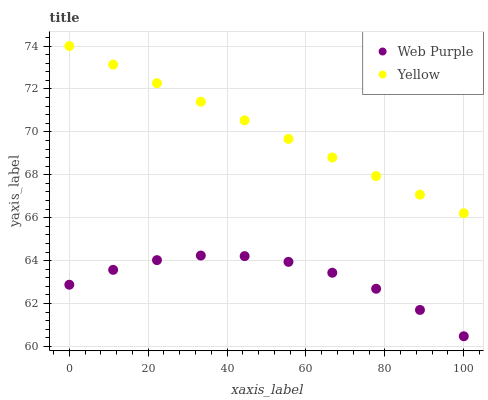Does Web Purple have the minimum area under the curve?
Answer yes or no. Yes. Does Yellow have the maximum area under the curve?
Answer yes or no. Yes. Does Yellow have the minimum area under the curve?
Answer yes or no. No. Is Yellow the smoothest?
Answer yes or no. Yes. Is Web Purple the roughest?
Answer yes or no. Yes. Is Yellow the roughest?
Answer yes or no. No. Does Web Purple have the lowest value?
Answer yes or no. Yes. Does Yellow have the lowest value?
Answer yes or no. No. Does Yellow have the highest value?
Answer yes or no. Yes. Is Web Purple less than Yellow?
Answer yes or no. Yes. Is Yellow greater than Web Purple?
Answer yes or no. Yes. Does Web Purple intersect Yellow?
Answer yes or no. No. 